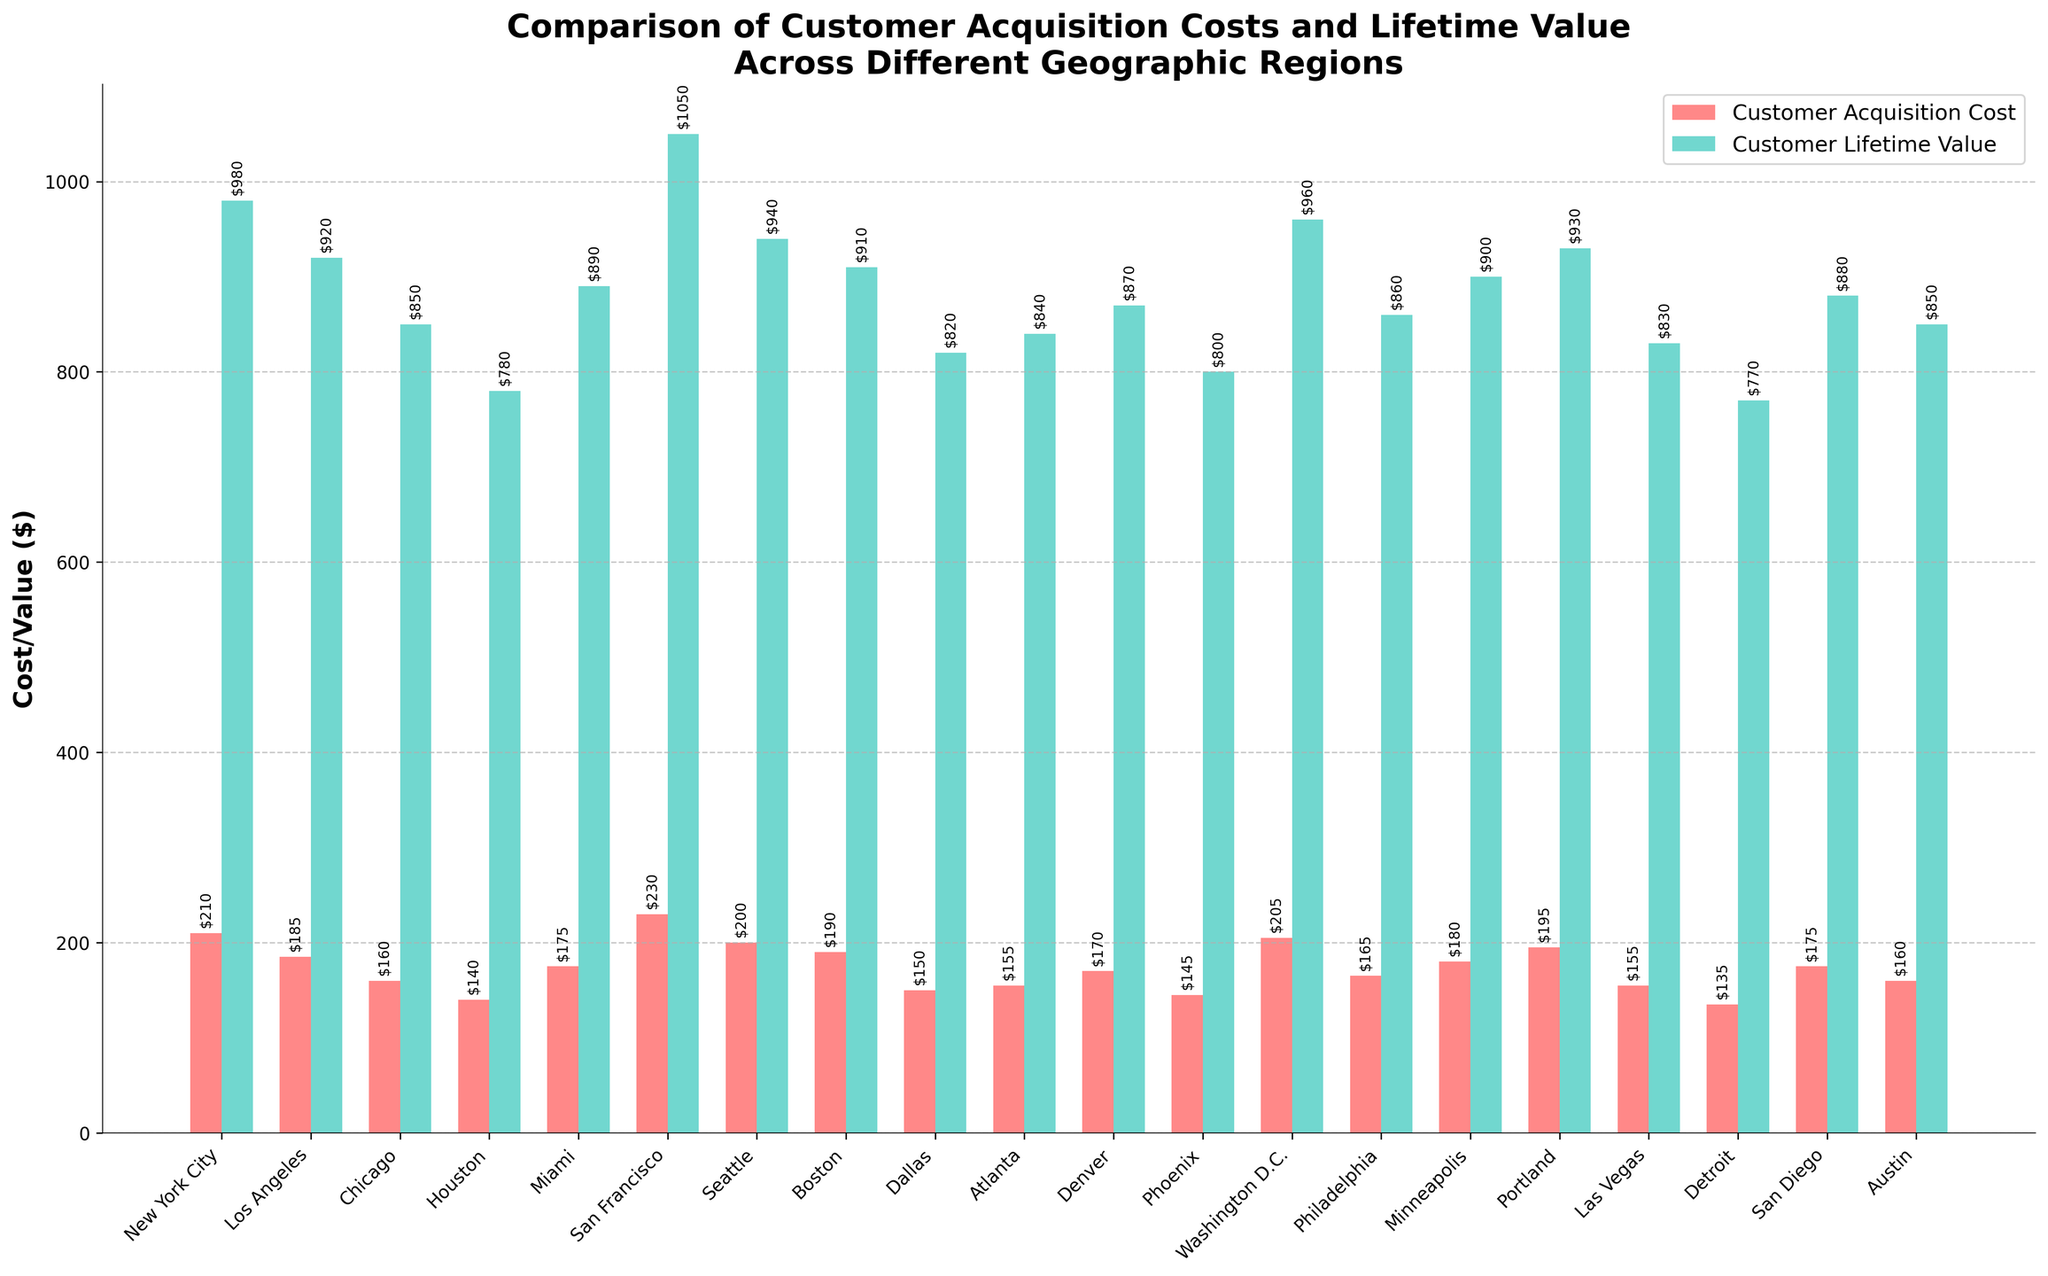What's the region with the highest Customer Lifetime Value? Look at the tallest green bar, which represents the Customer Lifetime Value. The tallest green bar corresponds to San Francisco.
Answer: San Francisco Which region has the lowest Customer Acquisition Cost? Look at the shortest red bar, which represents the Customer Acquisition Cost. The shortest red bar corresponds to Detroit.
Answer: Detroit What is the difference between the Customer Lifetime Value and Customer Acquisition Cost in New York City? The Customer Lifetime Value in New York City is 980, and the Customer Acquisition Cost is 210. The difference is calculated as 980 - 210.
Answer: 770 How does the Customer Acquisition Cost in San Francisco compare to that in Los Angeles? The Customer Acquisition Cost in San Francisco is 230, and in Los Angeles, it is 185. Compare these values directly.
Answer: San Francisco has a higher Customer Acquisition Cost than Los Angeles by 45 What is the average Customer Lifetime Value across all regions? Add up all the Customer Lifetime Values and then divide by the number of regions (20). The sum is 980 + 920 + 850 + 780 + 890 + 1050 + 940 + 910 + 820 + 840 + 870 + 800 + 960 + 860 + 900 + 930 + 830 + 770 + 880 + 850. The calculation is: (980 + 920 + 850 + 780 + 890 + 1050 + 940 + 910 + 820 + 840 + 870 + 800 + 960 + 860 + 900 + 930 + 830 + 770 + 880 + 850) / 20.
Answer: 876.5 Which regions have Customer Lifetime Values higher than $900? Identify the green bars that have a value greater than 900. These regions are New York City, San Francisco, Seattle, Boston, Washington D.C., and Portland.
Answer: New York City, San Francisco, Seattle, Boston, Washington D.C., Portland What's the total Customer Acquisition Cost for Dallas and Detroit combined? Add the Customer Acquisition Cost for Dallas and Detroit. The values are 150 for Dallas and 135 for Detroit. The sum is 150 + 135.
Answer: 285 Is the Customer Lifetime Value in Atlanta higher than in Chicago? Compare the green bar for Atlanta with the green bar for Chicago. Atlanta has a Customer Lifetime Value of 840, and Chicago has 850.
Answer: No What is the median Customer Acquisition Cost across all regions? Arrange all Customer Acquisition Costs in ascending order and find the middle value. The values are 135, 140, 145, 150, 155, 155, 160, 160, 165, 170, 175, 175, 180, 185, 190, 195, 200, 205, 210, 230. The median is the average of the 10th and 11th values (165 and 170). The calculation is (165 + 170) / 2.
Answer: 167.5 Which region has a Customer Lifetime Value exactly $870? Identify the green bar with the value of 870. This value corresponds to Denver.
Answer: Denver 